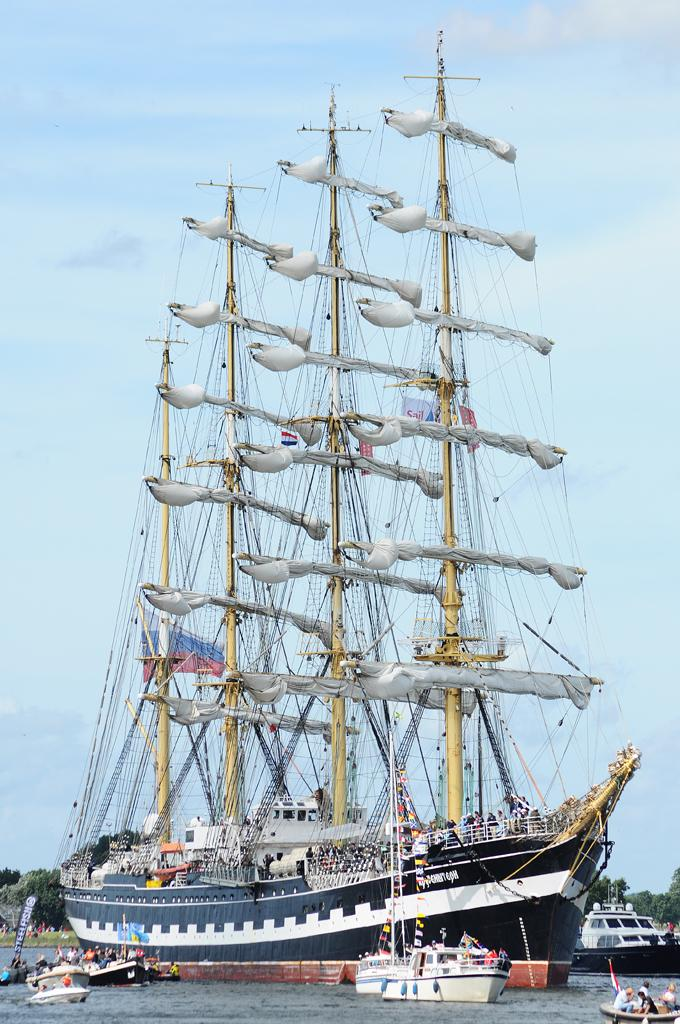<image>
Provide a brief description of the given image. People are holding a Steelfish sign from a small boat that is next to a large ship. 